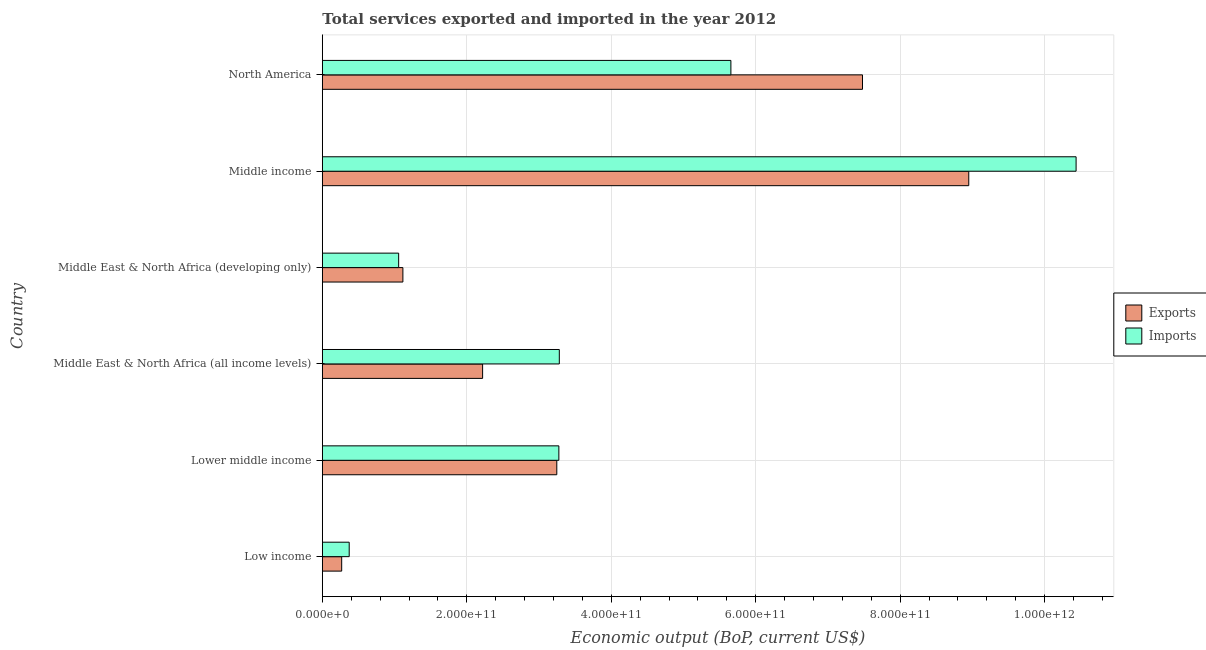Are the number of bars per tick equal to the number of legend labels?
Give a very brief answer. Yes. Are the number of bars on each tick of the Y-axis equal?
Your answer should be compact. Yes. What is the label of the 1st group of bars from the top?
Your response must be concise. North America. In how many cases, is the number of bars for a given country not equal to the number of legend labels?
Your answer should be very brief. 0. What is the amount of service imports in Low income?
Your answer should be compact. 3.72e+1. Across all countries, what is the maximum amount of service exports?
Make the answer very short. 8.95e+11. Across all countries, what is the minimum amount of service imports?
Make the answer very short. 3.72e+1. In which country was the amount of service exports minimum?
Provide a succinct answer. Low income. What is the total amount of service exports in the graph?
Provide a short and direct response. 2.33e+12. What is the difference between the amount of service imports in Lower middle income and that in Middle East & North Africa (all income levels)?
Offer a terse response. -6.35e+08. What is the difference between the amount of service imports in Middle income and the amount of service exports in Middle East & North Africa (developing only)?
Keep it short and to the point. 9.32e+11. What is the average amount of service imports per country?
Ensure brevity in your answer.  4.01e+11. What is the difference between the amount of service imports and amount of service exports in Middle East & North Africa (developing only)?
Provide a succinct answer. -5.86e+09. In how many countries, is the amount of service exports greater than 720000000000 US$?
Provide a short and direct response. 2. What is the ratio of the amount of service exports in Middle East & North Africa (all income levels) to that in Middle income?
Make the answer very short. 0.25. Is the difference between the amount of service exports in Middle East & North Africa (all income levels) and Middle East & North Africa (developing only) greater than the difference between the amount of service imports in Middle East & North Africa (all income levels) and Middle East & North Africa (developing only)?
Offer a terse response. No. What is the difference between the highest and the second highest amount of service exports?
Your answer should be very brief. 1.47e+11. What is the difference between the highest and the lowest amount of service exports?
Your answer should be compact. 8.68e+11. In how many countries, is the amount of service imports greater than the average amount of service imports taken over all countries?
Provide a succinct answer. 2. Is the sum of the amount of service exports in Middle income and North America greater than the maximum amount of service imports across all countries?
Ensure brevity in your answer.  Yes. What does the 2nd bar from the top in Middle income represents?
Your response must be concise. Exports. What does the 1st bar from the bottom in Lower middle income represents?
Your answer should be compact. Exports. How many bars are there?
Your answer should be very brief. 12. Are all the bars in the graph horizontal?
Keep it short and to the point. Yes. How many countries are there in the graph?
Ensure brevity in your answer.  6. What is the difference between two consecutive major ticks on the X-axis?
Give a very brief answer. 2.00e+11. Does the graph contain any zero values?
Your answer should be very brief. No. Does the graph contain grids?
Your response must be concise. Yes. How are the legend labels stacked?
Offer a very short reply. Vertical. What is the title of the graph?
Your answer should be compact. Total services exported and imported in the year 2012. Does "Female population" appear as one of the legend labels in the graph?
Provide a succinct answer. No. What is the label or title of the X-axis?
Your response must be concise. Economic output (BoP, current US$). What is the Economic output (BoP, current US$) in Exports in Low income?
Give a very brief answer. 2.68e+1. What is the Economic output (BoP, current US$) of Imports in Low income?
Give a very brief answer. 3.72e+1. What is the Economic output (BoP, current US$) of Exports in Lower middle income?
Your answer should be compact. 3.25e+11. What is the Economic output (BoP, current US$) of Imports in Lower middle income?
Give a very brief answer. 3.27e+11. What is the Economic output (BoP, current US$) of Exports in Middle East & North Africa (all income levels)?
Give a very brief answer. 2.22e+11. What is the Economic output (BoP, current US$) of Imports in Middle East & North Africa (all income levels)?
Offer a very short reply. 3.28e+11. What is the Economic output (BoP, current US$) of Exports in Middle East & North Africa (developing only)?
Your answer should be very brief. 1.12e+11. What is the Economic output (BoP, current US$) of Imports in Middle East & North Africa (developing only)?
Your answer should be very brief. 1.06e+11. What is the Economic output (BoP, current US$) of Exports in Middle income?
Provide a succinct answer. 8.95e+11. What is the Economic output (BoP, current US$) in Imports in Middle income?
Your response must be concise. 1.04e+12. What is the Economic output (BoP, current US$) of Exports in North America?
Offer a very short reply. 7.48e+11. What is the Economic output (BoP, current US$) of Imports in North America?
Offer a terse response. 5.66e+11. Across all countries, what is the maximum Economic output (BoP, current US$) of Exports?
Ensure brevity in your answer.  8.95e+11. Across all countries, what is the maximum Economic output (BoP, current US$) of Imports?
Make the answer very short. 1.04e+12. Across all countries, what is the minimum Economic output (BoP, current US$) in Exports?
Offer a terse response. 2.68e+1. Across all countries, what is the minimum Economic output (BoP, current US$) of Imports?
Offer a very short reply. 3.72e+1. What is the total Economic output (BoP, current US$) of Exports in the graph?
Provide a succinct answer. 2.33e+12. What is the total Economic output (BoP, current US$) in Imports in the graph?
Provide a succinct answer. 2.41e+12. What is the difference between the Economic output (BoP, current US$) in Exports in Low income and that in Lower middle income?
Provide a succinct answer. -2.98e+11. What is the difference between the Economic output (BoP, current US$) of Imports in Low income and that in Lower middle income?
Your response must be concise. -2.90e+11. What is the difference between the Economic output (BoP, current US$) in Exports in Low income and that in Middle East & North Africa (all income levels)?
Provide a succinct answer. -1.95e+11. What is the difference between the Economic output (BoP, current US$) of Imports in Low income and that in Middle East & North Africa (all income levels)?
Ensure brevity in your answer.  -2.91e+11. What is the difference between the Economic output (BoP, current US$) in Exports in Low income and that in Middle East & North Africa (developing only)?
Keep it short and to the point. -8.47e+1. What is the difference between the Economic output (BoP, current US$) in Imports in Low income and that in Middle East & North Africa (developing only)?
Offer a terse response. -6.85e+1. What is the difference between the Economic output (BoP, current US$) in Exports in Low income and that in Middle income?
Keep it short and to the point. -8.68e+11. What is the difference between the Economic output (BoP, current US$) of Imports in Low income and that in Middle income?
Your answer should be very brief. -1.01e+12. What is the difference between the Economic output (BoP, current US$) of Exports in Low income and that in North America?
Ensure brevity in your answer.  -7.21e+11. What is the difference between the Economic output (BoP, current US$) of Imports in Low income and that in North America?
Offer a very short reply. -5.28e+11. What is the difference between the Economic output (BoP, current US$) of Exports in Lower middle income and that in Middle East & North Africa (all income levels)?
Your response must be concise. 1.03e+11. What is the difference between the Economic output (BoP, current US$) of Imports in Lower middle income and that in Middle East & North Africa (all income levels)?
Ensure brevity in your answer.  -6.35e+08. What is the difference between the Economic output (BoP, current US$) in Exports in Lower middle income and that in Middle East & North Africa (developing only)?
Provide a succinct answer. 2.13e+11. What is the difference between the Economic output (BoP, current US$) in Imports in Lower middle income and that in Middle East & North Africa (developing only)?
Your answer should be compact. 2.22e+11. What is the difference between the Economic output (BoP, current US$) in Exports in Lower middle income and that in Middle income?
Your response must be concise. -5.70e+11. What is the difference between the Economic output (BoP, current US$) in Imports in Lower middle income and that in Middle income?
Provide a succinct answer. -7.16e+11. What is the difference between the Economic output (BoP, current US$) in Exports in Lower middle income and that in North America?
Your answer should be very brief. -4.23e+11. What is the difference between the Economic output (BoP, current US$) of Imports in Lower middle income and that in North America?
Make the answer very short. -2.38e+11. What is the difference between the Economic output (BoP, current US$) in Exports in Middle East & North Africa (all income levels) and that in Middle East & North Africa (developing only)?
Offer a terse response. 1.10e+11. What is the difference between the Economic output (BoP, current US$) in Imports in Middle East & North Africa (all income levels) and that in Middle East & North Africa (developing only)?
Make the answer very short. 2.22e+11. What is the difference between the Economic output (BoP, current US$) of Exports in Middle East & North Africa (all income levels) and that in Middle income?
Your answer should be very brief. -6.73e+11. What is the difference between the Economic output (BoP, current US$) in Imports in Middle East & North Africa (all income levels) and that in Middle income?
Offer a terse response. -7.15e+11. What is the difference between the Economic output (BoP, current US$) of Exports in Middle East & North Africa (all income levels) and that in North America?
Your answer should be compact. -5.26e+11. What is the difference between the Economic output (BoP, current US$) of Imports in Middle East & North Africa (all income levels) and that in North America?
Give a very brief answer. -2.38e+11. What is the difference between the Economic output (BoP, current US$) of Exports in Middle East & North Africa (developing only) and that in Middle income?
Give a very brief answer. -7.83e+11. What is the difference between the Economic output (BoP, current US$) in Imports in Middle East & North Africa (developing only) and that in Middle income?
Provide a succinct answer. -9.38e+11. What is the difference between the Economic output (BoP, current US$) in Exports in Middle East & North Africa (developing only) and that in North America?
Provide a succinct answer. -6.36e+11. What is the difference between the Economic output (BoP, current US$) in Imports in Middle East & North Africa (developing only) and that in North America?
Keep it short and to the point. -4.60e+11. What is the difference between the Economic output (BoP, current US$) of Exports in Middle income and that in North America?
Your answer should be very brief. 1.47e+11. What is the difference between the Economic output (BoP, current US$) of Imports in Middle income and that in North America?
Your answer should be very brief. 4.78e+11. What is the difference between the Economic output (BoP, current US$) of Exports in Low income and the Economic output (BoP, current US$) of Imports in Lower middle income?
Make the answer very short. -3.01e+11. What is the difference between the Economic output (BoP, current US$) of Exports in Low income and the Economic output (BoP, current US$) of Imports in Middle East & North Africa (all income levels)?
Offer a terse response. -3.01e+11. What is the difference between the Economic output (BoP, current US$) in Exports in Low income and the Economic output (BoP, current US$) in Imports in Middle East & North Africa (developing only)?
Offer a terse response. -7.89e+1. What is the difference between the Economic output (BoP, current US$) of Exports in Low income and the Economic output (BoP, current US$) of Imports in Middle income?
Make the answer very short. -1.02e+12. What is the difference between the Economic output (BoP, current US$) in Exports in Low income and the Economic output (BoP, current US$) in Imports in North America?
Provide a succinct answer. -5.39e+11. What is the difference between the Economic output (BoP, current US$) of Exports in Lower middle income and the Economic output (BoP, current US$) of Imports in Middle East & North Africa (all income levels)?
Provide a succinct answer. -3.48e+09. What is the difference between the Economic output (BoP, current US$) of Exports in Lower middle income and the Economic output (BoP, current US$) of Imports in Middle East & North Africa (developing only)?
Offer a very short reply. 2.19e+11. What is the difference between the Economic output (BoP, current US$) of Exports in Lower middle income and the Economic output (BoP, current US$) of Imports in Middle income?
Provide a succinct answer. -7.19e+11. What is the difference between the Economic output (BoP, current US$) in Exports in Lower middle income and the Economic output (BoP, current US$) in Imports in North America?
Ensure brevity in your answer.  -2.41e+11. What is the difference between the Economic output (BoP, current US$) in Exports in Middle East & North Africa (all income levels) and the Economic output (BoP, current US$) in Imports in Middle East & North Africa (developing only)?
Keep it short and to the point. 1.16e+11. What is the difference between the Economic output (BoP, current US$) of Exports in Middle East & North Africa (all income levels) and the Economic output (BoP, current US$) of Imports in Middle income?
Keep it short and to the point. -8.22e+11. What is the difference between the Economic output (BoP, current US$) of Exports in Middle East & North Africa (all income levels) and the Economic output (BoP, current US$) of Imports in North America?
Provide a short and direct response. -3.44e+11. What is the difference between the Economic output (BoP, current US$) of Exports in Middle East & North Africa (developing only) and the Economic output (BoP, current US$) of Imports in Middle income?
Provide a succinct answer. -9.32e+11. What is the difference between the Economic output (BoP, current US$) in Exports in Middle East & North Africa (developing only) and the Economic output (BoP, current US$) in Imports in North America?
Give a very brief answer. -4.54e+11. What is the difference between the Economic output (BoP, current US$) in Exports in Middle income and the Economic output (BoP, current US$) in Imports in North America?
Your answer should be very brief. 3.29e+11. What is the average Economic output (BoP, current US$) of Exports per country?
Offer a terse response. 3.88e+11. What is the average Economic output (BoP, current US$) of Imports per country?
Your answer should be compact. 4.01e+11. What is the difference between the Economic output (BoP, current US$) of Exports and Economic output (BoP, current US$) of Imports in Low income?
Give a very brief answer. -1.04e+1. What is the difference between the Economic output (BoP, current US$) of Exports and Economic output (BoP, current US$) of Imports in Lower middle income?
Ensure brevity in your answer.  -2.84e+09. What is the difference between the Economic output (BoP, current US$) of Exports and Economic output (BoP, current US$) of Imports in Middle East & North Africa (all income levels)?
Offer a very short reply. -1.06e+11. What is the difference between the Economic output (BoP, current US$) in Exports and Economic output (BoP, current US$) in Imports in Middle East & North Africa (developing only)?
Offer a very short reply. 5.86e+09. What is the difference between the Economic output (BoP, current US$) in Exports and Economic output (BoP, current US$) in Imports in Middle income?
Make the answer very short. -1.49e+11. What is the difference between the Economic output (BoP, current US$) in Exports and Economic output (BoP, current US$) in Imports in North America?
Your answer should be compact. 1.82e+11. What is the ratio of the Economic output (BoP, current US$) in Exports in Low income to that in Lower middle income?
Give a very brief answer. 0.08. What is the ratio of the Economic output (BoP, current US$) of Imports in Low income to that in Lower middle income?
Keep it short and to the point. 0.11. What is the ratio of the Economic output (BoP, current US$) in Exports in Low income to that in Middle East & North Africa (all income levels)?
Provide a short and direct response. 0.12. What is the ratio of the Economic output (BoP, current US$) of Imports in Low income to that in Middle East & North Africa (all income levels)?
Provide a succinct answer. 0.11. What is the ratio of the Economic output (BoP, current US$) in Exports in Low income to that in Middle East & North Africa (developing only)?
Keep it short and to the point. 0.24. What is the ratio of the Economic output (BoP, current US$) of Imports in Low income to that in Middle East & North Africa (developing only)?
Provide a short and direct response. 0.35. What is the ratio of the Economic output (BoP, current US$) of Exports in Low income to that in Middle income?
Offer a very short reply. 0.03. What is the ratio of the Economic output (BoP, current US$) in Imports in Low income to that in Middle income?
Offer a terse response. 0.04. What is the ratio of the Economic output (BoP, current US$) in Exports in Low income to that in North America?
Provide a succinct answer. 0.04. What is the ratio of the Economic output (BoP, current US$) in Imports in Low income to that in North America?
Keep it short and to the point. 0.07. What is the ratio of the Economic output (BoP, current US$) in Exports in Lower middle income to that in Middle East & North Africa (all income levels)?
Offer a very short reply. 1.46. What is the ratio of the Economic output (BoP, current US$) of Exports in Lower middle income to that in Middle East & North Africa (developing only)?
Your answer should be very brief. 2.91. What is the ratio of the Economic output (BoP, current US$) of Imports in Lower middle income to that in Middle East & North Africa (developing only)?
Offer a very short reply. 3.1. What is the ratio of the Economic output (BoP, current US$) in Exports in Lower middle income to that in Middle income?
Your answer should be compact. 0.36. What is the ratio of the Economic output (BoP, current US$) in Imports in Lower middle income to that in Middle income?
Keep it short and to the point. 0.31. What is the ratio of the Economic output (BoP, current US$) in Exports in Lower middle income to that in North America?
Offer a very short reply. 0.43. What is the ratio of the Economic output (BoP, current US$) of Imports in Lower middle income to that in North America?
Provide a succinct answer. 0.58. What is the ratio of the Economic output (BoP, current US$) of Exports in Middle East & North Africa (all income levels) to that in Middle East & North Africa (developing only)?
Offer a terse response. 1.99. What is the ratio of the Economic output (BoP, current US$) of Imports in Middle East & North Africa (all income levels) to that in Middle East & North Africa (developing only)?
Your answer should be very brief. 3.1. What is the ratio of the Economic output (BoP, current US$) in Exports in Middle East & North Africa (all income levels) to that in Middle income?
Ensure brevity in your answer.  0.25. What is the ratio of the Economic output (BoP, current US$) in Imports in Middle East & North Africa (all income levels) to that in Middle income?
Your answer should be very brief. 0.31. What is the ratio of the Economic output (BoP, current US$) in Exports in Middle East & North Africa (all income levels) to that in North America?
Provide a short and direct response. 0.3. What is the ratio of the Economic output (BoP, current US$) of Imports in Middle East & North Africa (all income levels) to that in North America?
Offer a terse response. 0.58. What is the ratio of the Economic output (BoP, current US$) of Exports in Middle East & North Africa (developing only) to that in Middle income?
Your response must be concise. 0.12. What is the ratio of the Economic output (BoP, current US$) in Imports in Middle East & North Africa (developing only) to that in Middle income?
Your answer should be very brief. 0.1. What is the ratio of the Economic output (BoP, current US$) of Exports in Middle East & North Africa (developing only) to that in North America?
Make the answer very short. 0.15. What is the ratio of the Economic output (BoP, current US$) of Imports in Middle East & North Africa (developing only) to that in North America?
Provide a succinct answer. 0.19. What is the ratio of the Economic output (BoP, current US$) in Exports in Middle income to that in North America?
Your answer should be compact. 1.2. What is the ratio of the Economic output (BoP, current US$) of Imports in Middle income to that in North America?
Offer a very short reply. 1.84. What is the difference between the highest and the second highest Economic output (BoP, current US$) in Exports?
Offer a very short reply. 1.47e+11. What is the difference between the highest and the second highest Economic output (BoP, current US$) of Imports?
Your response must be concise. 4.78e+11. What is the difference between the highest and the lowest Economic output (BoP, current US$) of Exports?
Offer a very short reply. 8.68e+11. What is the difference between the highest and the lowest Economic output (BoP, current US$) in Imports?
Make the answer very short. 1.01e+12. 